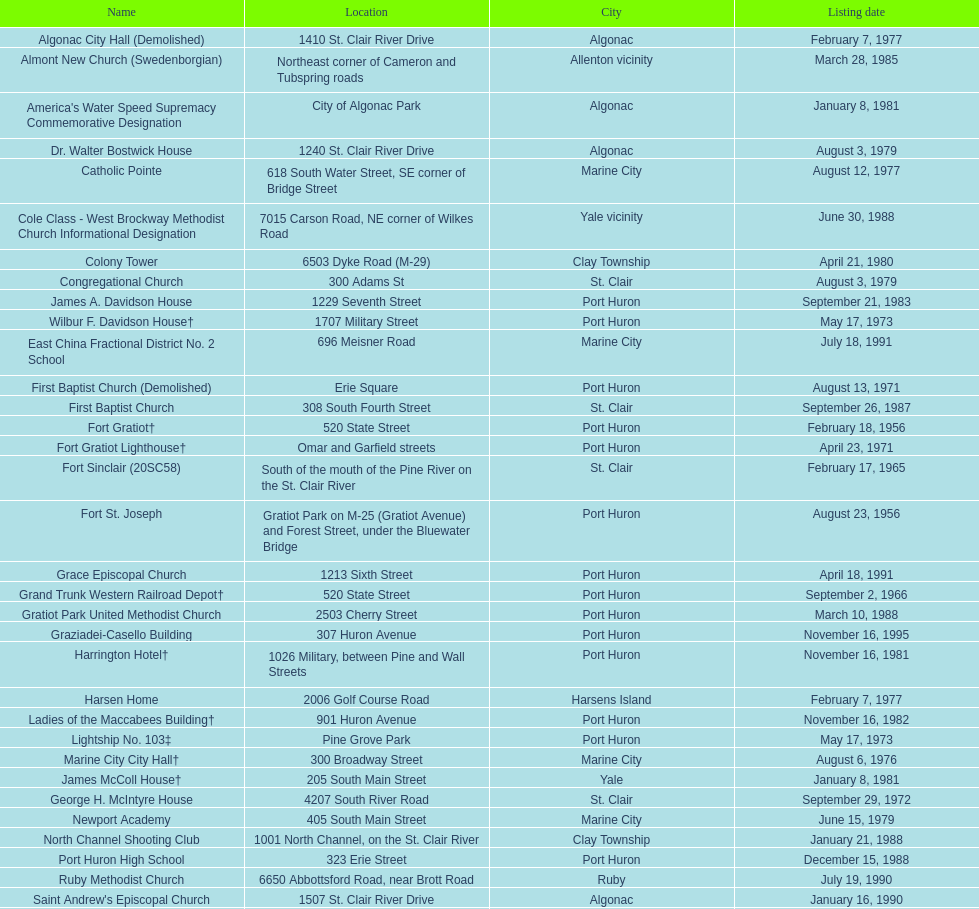What is the total number of locations in the city of algonac? 5. 